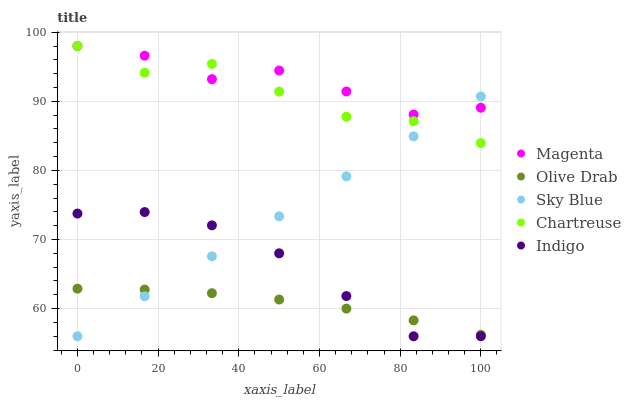Does Olive Drab have the minimum area under the curve?
Answer yes or no. Yes. Does Magenta have the maximum area under the curve?
Answer yes or no. Yes. Does Indigo have the minimum area under the curve?
Answer yes or no. No. Does Indigo have the maximum area under the curve?
Answer yes or no. No. Is Sky Blue the smoothest?
Answer yes or no. Yes. Is Chartreuse the roughest?
Answer yes or no. Yes. Is Magenta the smoothest?
Answer yes or no. No. Is Magenta the roughest?
Answer yes or no. No. Does Sky Blue have the lowest value?
Answer yes or no. Yes. Does Magenta have the lowest value?
Answer yes or no. No. Does Chartreuse have the highest value?
Answer yes or no. Yes. Does Indigo have the highest value?
Answer yes or no. No. Is Indigo less than Chartreuse?
Answer yes or no. Yes. Is Magenta greater than Indigo?
Answer yes or no. Yes. Does Olive Drab intersect Sky Blue?
Answer yes or no. Yes. Is Olive Drab less than Sky Blue?
Answer yes or no. No. Is Olive Drab greater than Sky Blue?
Answer yes or no. No. Does Indigo intersect Chartreuse?
Answer yes or no. No. 